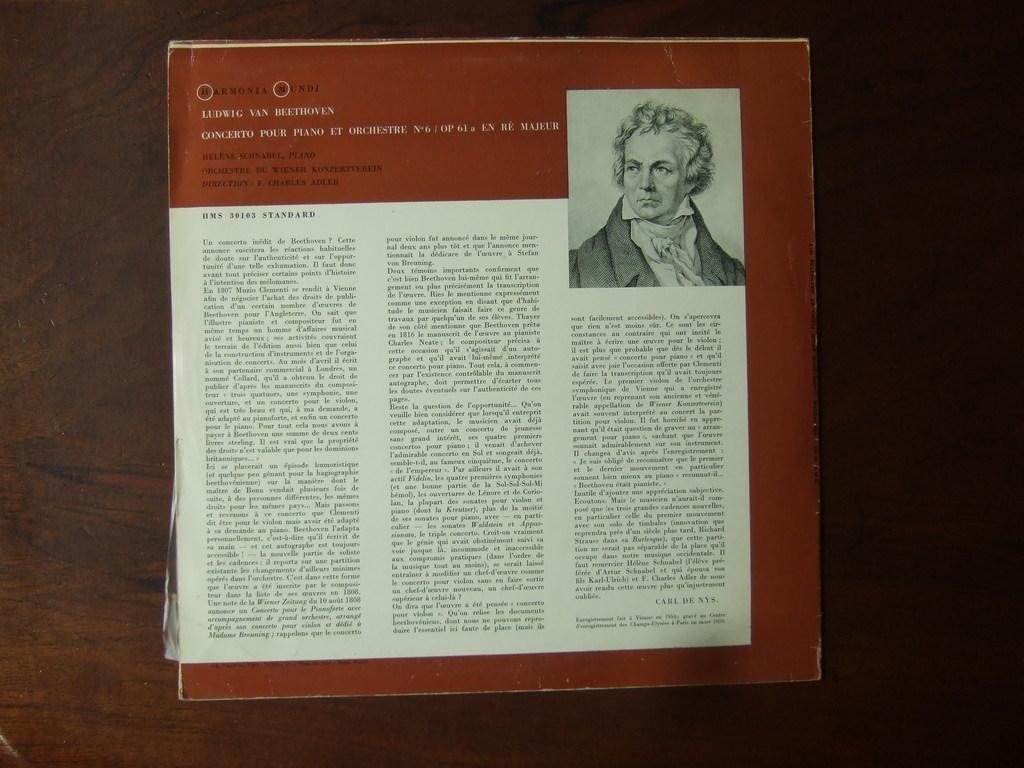Please provide a concise description of this image. In the center of the image we can see one paper on the wooden object. And we can see one person and some text on the paper. 